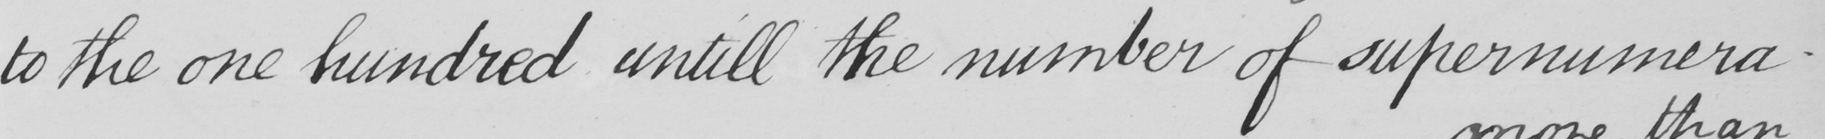Transcribe the text shown in this historical manuscript line. to the one hundred untill the number of supernumera- 